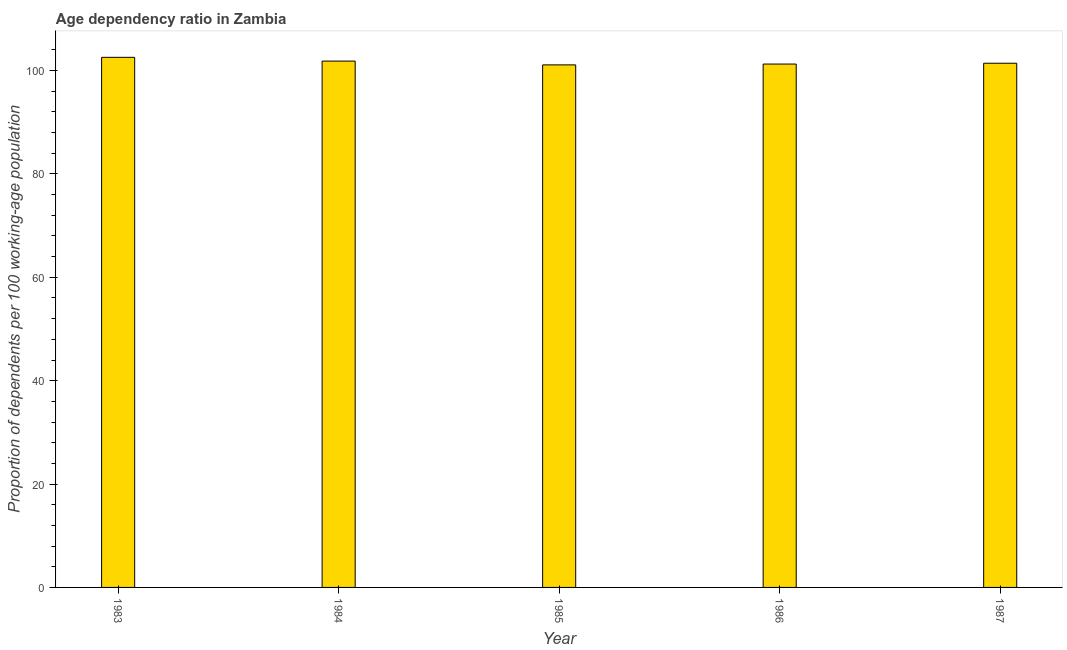Does the graph contain grids?
Your answer should be compact. No. What is the title of the graph?
Provide a short and direct response. Age dependency ratio in Zambia. What is the label or title of the X-axis?
Ensure brevity in your answer.  Year. What is the label or title of the Y-axis?
Offer a very short reply. Proportion of dependents per 100 working-age population. What is the age dependency ratio in 1985?
Give a very brief answer. 101.1. Across all years, what is the maximum age dependency ratio?
Keep it short and to the point. 102.56. Across all years, what is the minimum age dependency ratio?
Your answer should be very brief. 101.1. In which year was the age dependency ratio maximum?
Make the answer very short. 1983. What is the sum of the age dependency ratio?
Ensure brevity in your answer.  508.18. What is the difference between the age dependency ratio in 1986 and 1987?
Provide a succinct answer. -0.16. What is the average age dependency ratio per year?
Provide a short and direct response. 101.64. What is the median age dependency ratio?
Your response must be concise. 101.42. Do a majority of the years between 1986 and 1985 (inclusive) have age dependency ratio greater than 68 ?
Keep it short and to the point. No. What is the ratio of the age dependency ratio in 1985 to that in 1987?
Offer a very short reply. 1. Is the age dependency ratio in 1983 less than that in 1986?
Keep it short and to the point. No. Is the difference between the age dependency ratio in 1984 and 1987 greater than the difference between any two years?
Provide a succinct answer. No. What is the difference between the highest and the second highest age dependency ratio?
Offer a very short reply. 0.73. Is the sum of the age dependency ratio in 1984 and 1985 greater than the maximum age dependency ratio across all years?
Keep it short and to the point. Yes. What is the difference between the highest and the lowest age dependency ratio?
Offer a terse response. 1.46. How many bars are there?
Your answer should be compact. 5. What is the difference between two consecutive major ticks on the Y-axis?
Ensure brevity in your answer.  20. Are the values on the major ticks of Y-axis written in scientific E-notation?
Offer a very short reply. No. What is the Proportion of dependents per 100 working-age population in 1983?
Offer a very short reply. 102.56. What is the Proportion of dependents per 100 working-age population in 1984?
Give a very brief answer. 101.84. What is the Proportion of dependents per 100 working-age population of 1985?
Keep it short and to the point. 101.1. What is the Proportion of dependents per 100 working-age population in 1986?
Offer a very short reply. 101.26. What is the Proportion of dependents per 100 working-age population in 1987?
Provide a succinct answer. 101.42. What is the difference between the Proportion of dependents per 100 working-age population in 1983 and 1984?
Your response must be concise. 0.73. What is the difference between the Proportion of dependents per 100 working-age population in 1983 and 1985?
Keep it short and to the point. 1.46. What is the difference between the Proportion of dependents per 100 working-age population in 1983 and 1986?
Make the answer very short. 1.3. What is the difference between the Proportion of dependents per 100 working-age population in 1983 and 1987?
Give a very brief answer. 1.14. What is the difference between the Proportion of dependents per 100 working-age population in 1984 and 1985?
Offer a very short reply. 0.74. What is the difference between the Proportion of dependents per 100 working-age population in 1984 and 1986?
Provide a short and direct response. 0.57. What is the difference between the Proportion of dependents per 100 working-age population in 1984 and 1987?
Ensure brevity in your answer.  0.42. What is the difference between the Proportion of dependents per 100 working-age population in 1985 and 1986?
Your response must be concise. -0.16. What is the difference between the Proportion of dependents per 100 working-age population in 1985 and 1987?
Offer a terse response. -0.32. What is the difference between the Proportion of dependents per 100 working-age population in 1986 and 1987?
Your answer should be compact. -0.16. What is the ratio of the Proportion of dependents per 100 working-age population in 1983 to that in 1986?
Keep it short and to the point. 1.01. What is the ratio of the Proportion of dependents per 100 working-age population in 1983 to that in 1987?
Give a very brief answer. 1.01. What is the ratio of the Proportion of dependents per 100 working-age population in 1984 to that in 1986?
Your answer should be very brief. 1.01. What is the ratio of the Proportion of dependents per 100 working-age population in 1985 to that in 1987?
Your response must be concise. 1. What is the ratio of the Proportion of dependents per 100 working-age population in 1986 to that in 1987?
Make the answer very short. 1. 